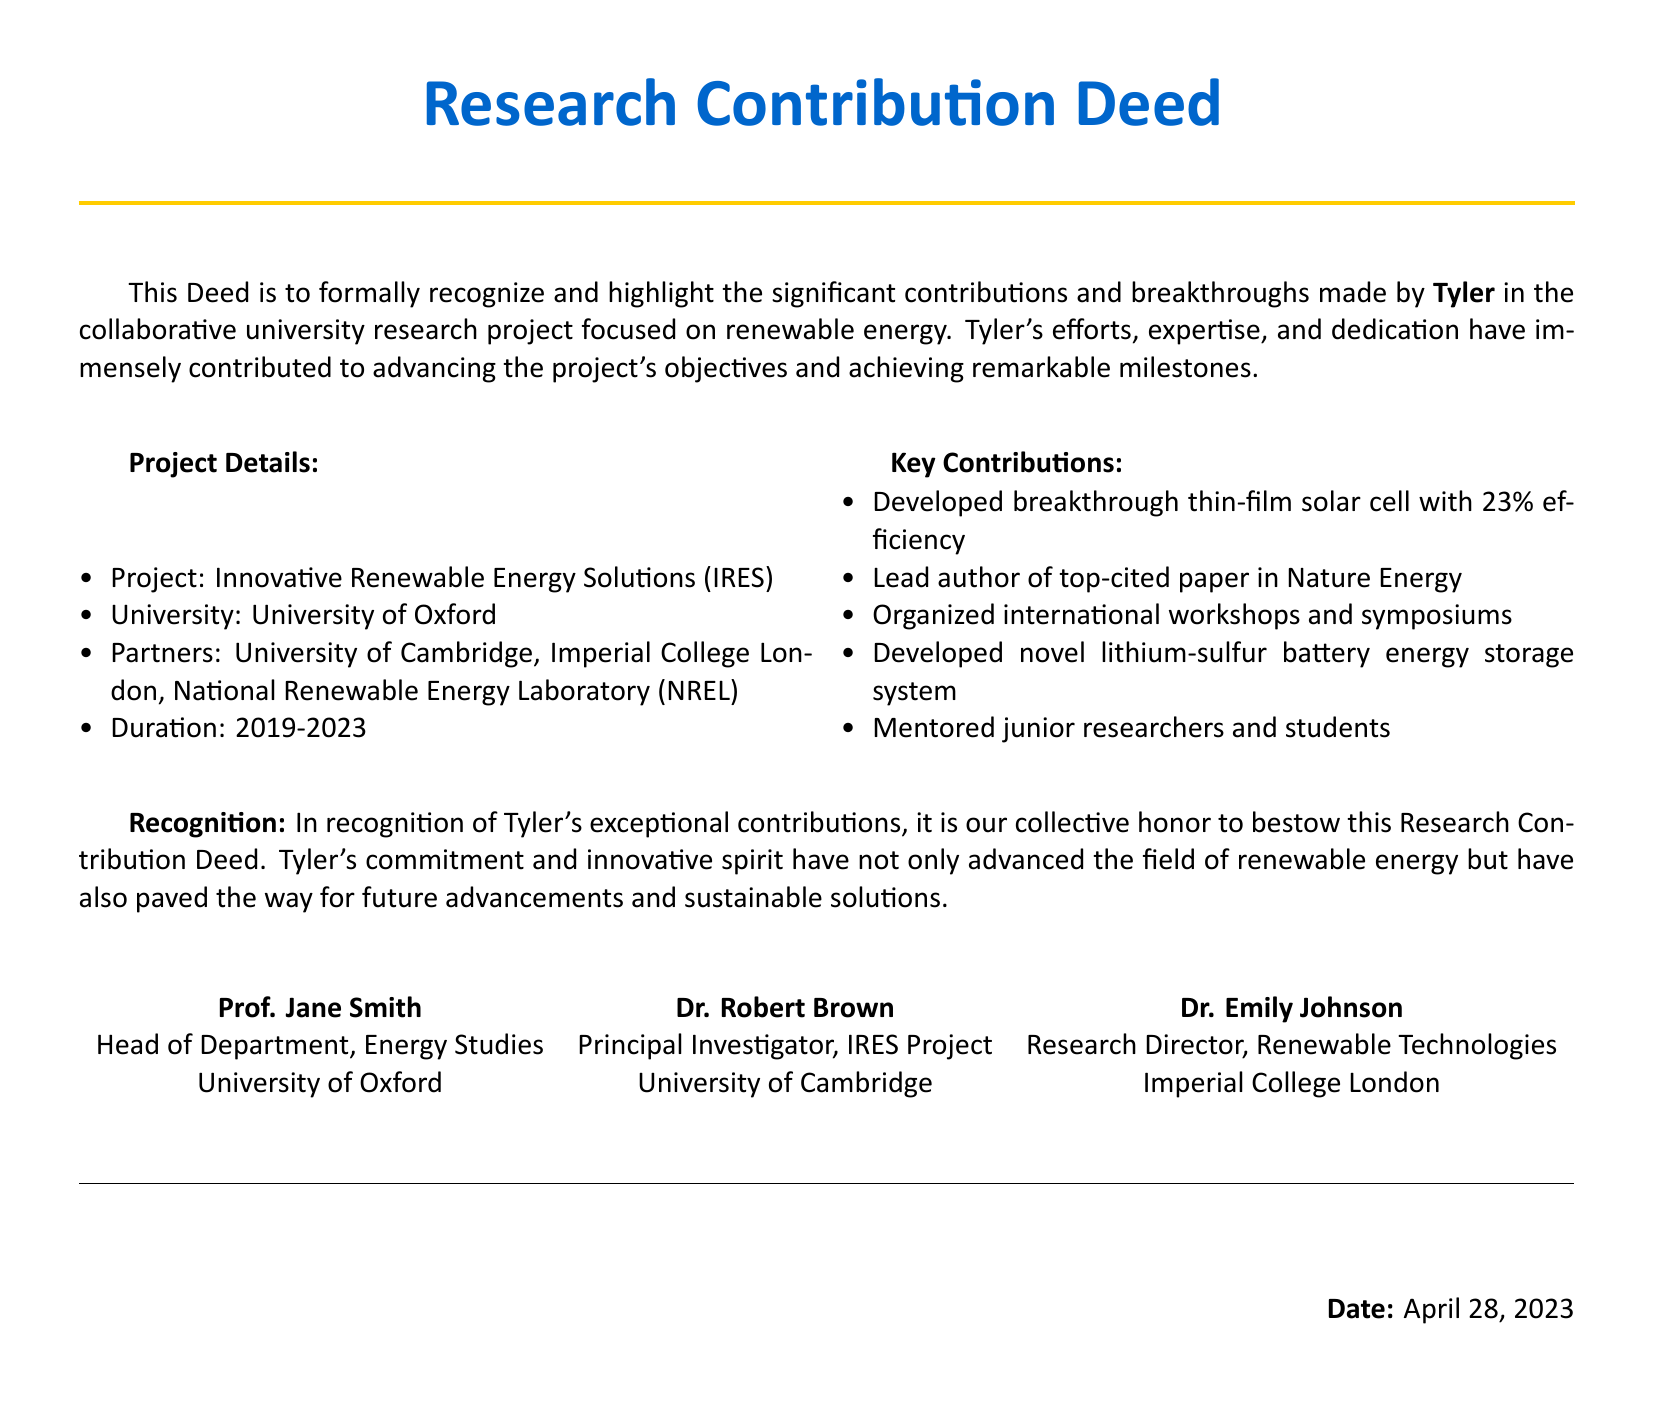What is the project name? The project name is specified as "Innovative Renewable Energy Solutions (IRES)" in the document.
Answer: Innovative Renewable Energy Solutions (IRES) Who is the lead author of the top-cited paper? The document indicates that Tyler is the lead author of the top-cited paper in Nature Energy.
Answer: Tyler What was the efficiency of the developed thin-film solar cell? The efficiency of the thin-film solar cell developed by Tyler is mentioned as 23%.
Answer: 23% What year did the project start? The start year of the project, as stated in the document, is 2019.
Answer: 2019 What university is listed as Tyler's affiliated institution? The document identifies the affiliated institution of the project as the University of Oxford.
Answer: University of Oxford How long did the project last? The project duration is specified in the document as from 2019 to 2023, which is a span of 4 years.
Answer: 4 years What type of battery system did Tyler develop? The document mentions that Tyler developed a novel lithium-sulfur battery energy storage system.
Answer: lithium-sulfur battery energy storage system Who recognized Tyler's contributions through this Deed? Recognition of Tyler's contributions is collectively honored by the signatories, including Prof. Jane Smith, Dr. Robert Brown, and Dr. Emily Johnson.
Answer: Prof. Jane Smith, Dr. Robert Brown, Dr. Emily Johnson What date was this Deed signed? The document specifies that the Deed was signed on April 28, 2023.
Answer: April 28, 2023 